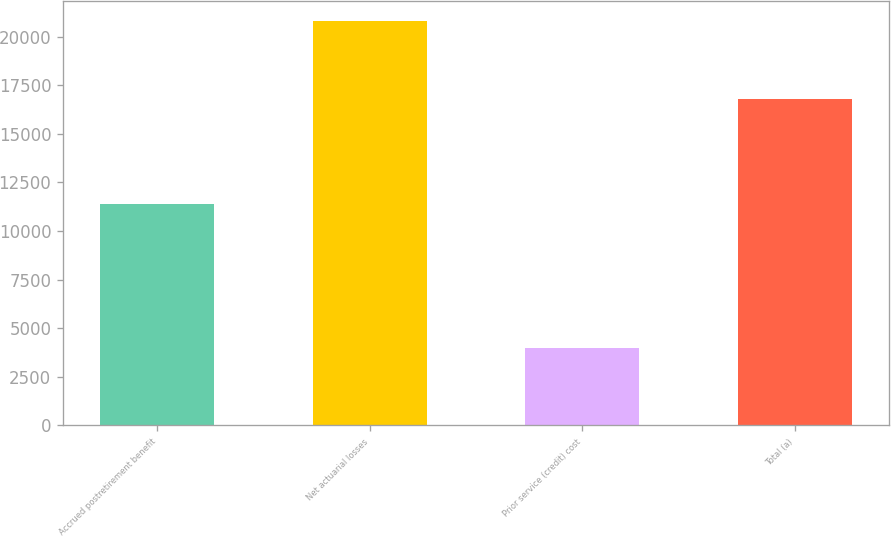Convert chart. <chart><loc_0><loc_0><loc_500><loc_500><bar_chart><fcel>Accrued postretirement benefit<fcel>Net actuarial losses<fcel>Prior service (credit) cost<fcel>Total (a)<nl><fcel>11413<fcel>20794<fcel>3985<fcel>16809<nl></chart> 